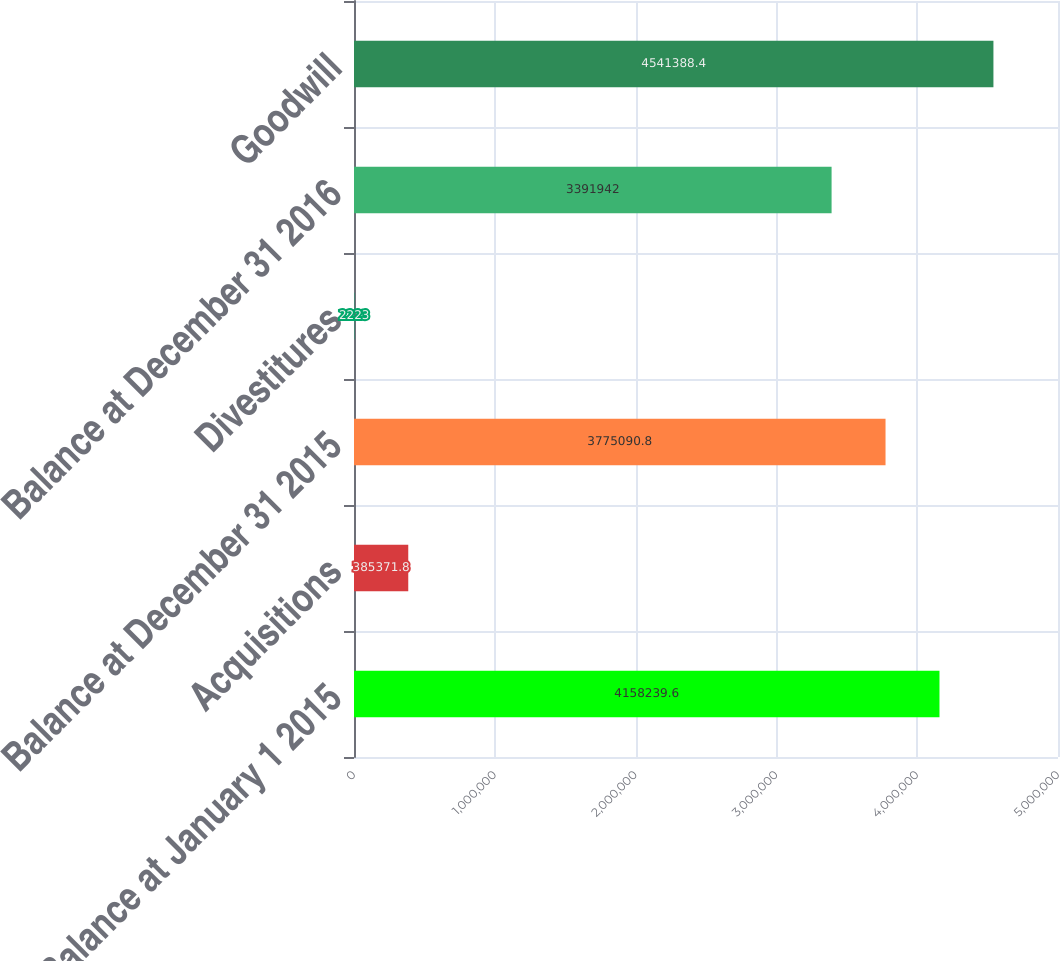<chart> <loc_0><loc_0><loc_500><loc_500><bar_chart><fcel>Balance at January 1 2015<fcel>Acquisitions<fcel>Balance at December 31 2015<fcel>Divestitures<fcel>Balance at December 31 2016<fcel>Goodwill<nl><fcel>4.15824e+06<fcel>385372<fcel>3.77509e+06<fcel>2223<fcel>3.39194e+06<fcel>4.54139e+06<nl></chart> 